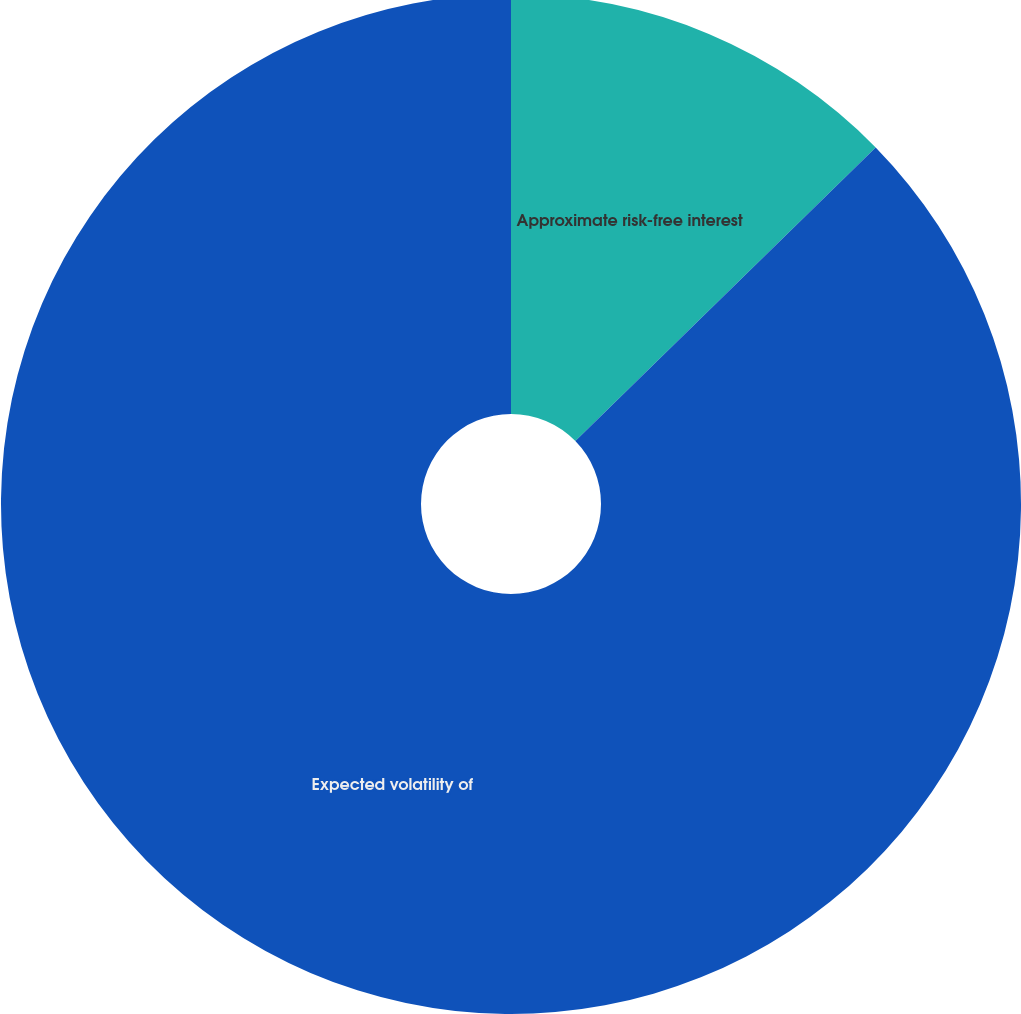Convert chart to OTSL. <chart><loc_0><loc_0><loc_500><loc_500><pie_chart><fcel>Approximate risk-free interest<fcel>Expected volatility of<nl><fcel>12.68%<fcel>87.32%<nl></chart> 